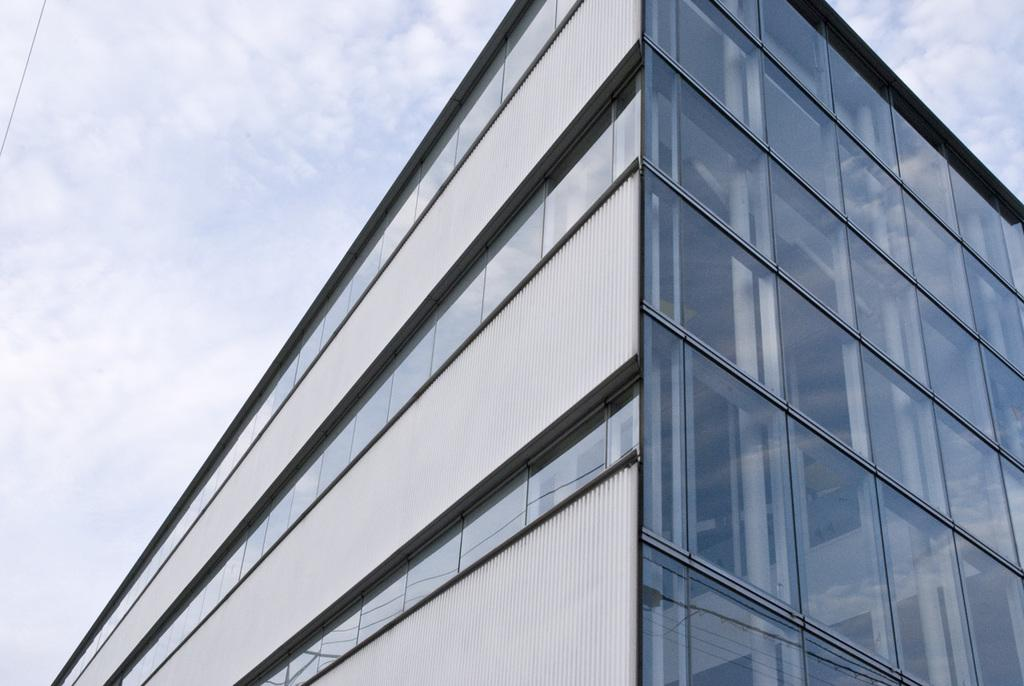What is located at the bottom of the image? There is a building at the bottom of the image. What can be seen in the sky behind the building? There are clouds in the sky behind the building. Can you see a bird playing volleyball on the seashore in the image? There is no bird, volleyball, or seashore present in the image. 